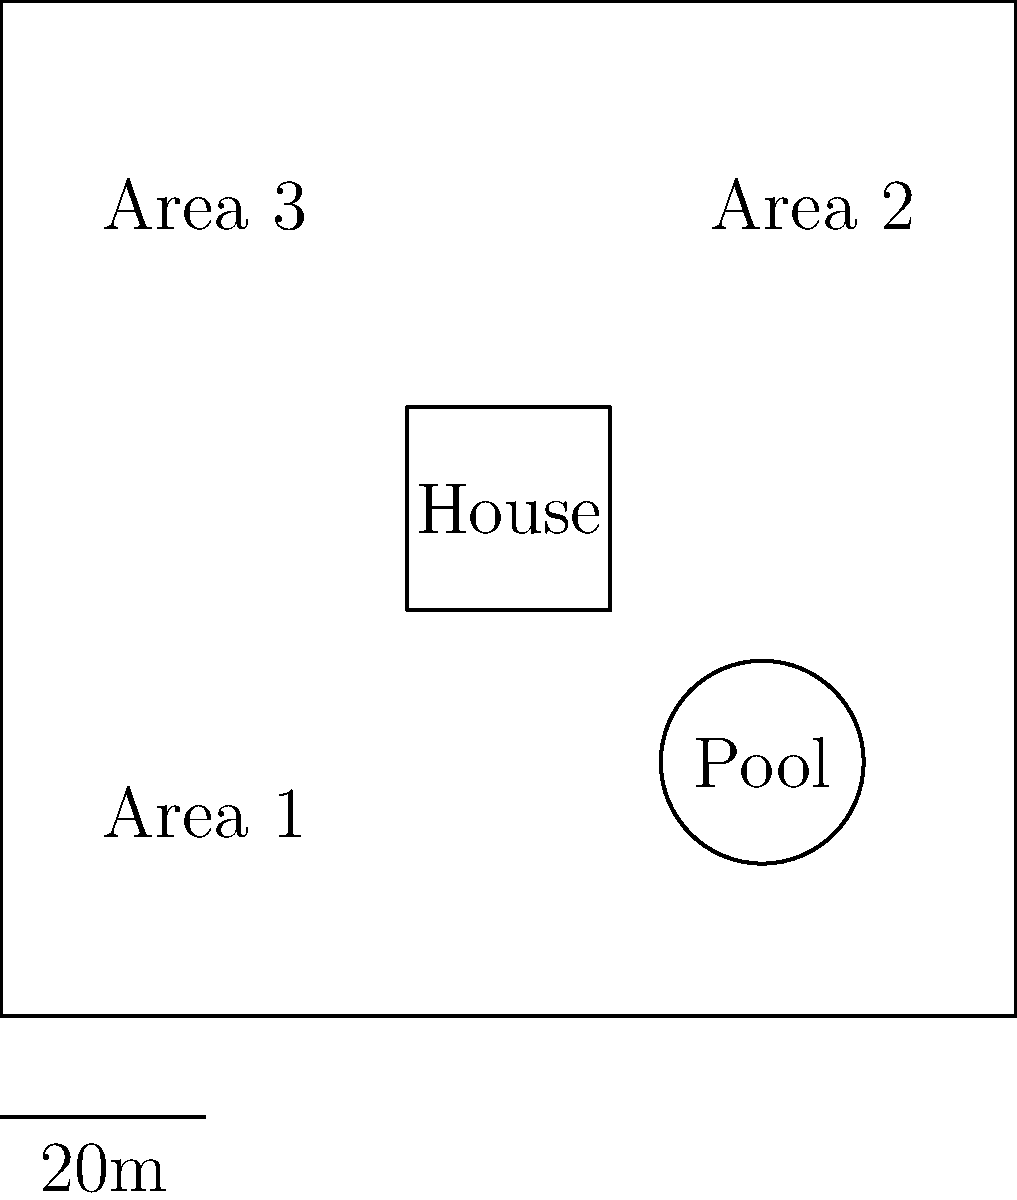Given the property map above and the following plant pricing information:
- Shrubs: $50 per square meter
- Flowers: $30 per square meter
- Grass: $10 per square meter

Which combination of plantings for Areas 1, 2, and 3 will result in the lowest total cost while ensuring each area has a different type of planting? To solve this problem, we need to follow these steps:

1. Calculate the area of each planting zone:
   Area 1: $30m \times 30m = 900m^2$
   Area 2: $30m \times 30m = 900m^2$
   Area 3: $30m \times 30m = 900m^2$

2. Calculate the cost for each type of planting in each area:
   Shrubs: $900m^2 \times $50/m^2 = $45,000$
   Flowers: $900m^2 \times $30/m^2 = $27,000$
   Grass: $900m^2 \times $10/m^2 = $9,000$

3. To minimize the total cost while ensuring each area has a different type of planting, we need to assign the least expensive option (grass) to the largest area, the mid-priced option (flowers) to one area, and the most expensive option (shrubs) to the remaining area.

4. Since all areas are the same size, we can assign plantings as follows:
   Area 1: Grass ($9,000)
   Area 2: Flowers ($27,000)
   Area 3: Shrubs ($45,000)

5. Calculate the total cost:
   $9,000 + $27,000 + $45,000 = $81,000$

This combination ensures that each area has a different type of planting while minimizing the total cost.
Answer: Area 1: Grass, Area 2: Flowers, Area 3: Shrubs 